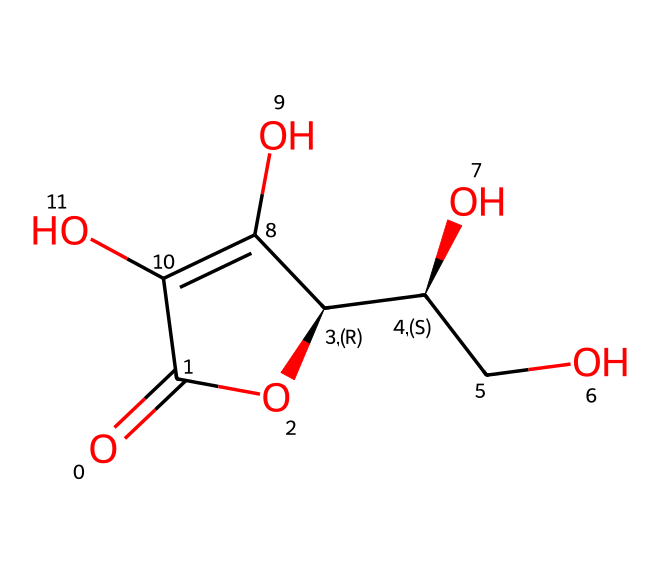How many carbon atoms are in ascorbic acid? To determine the number of carbon atoms, examine the structure and count each carbon atom present. The structure shows that there are 6 carbon atoms highlighted in the backbone of the molecule.
Answer: 6 What functional groups are present in ascorbic acid? By analyzing the structural representation, we can identify hydroxyl (-OH) groups and a carbonyl (C=O) group. These groups indicate that the chemical has alcohol and aldehyde functionalities.
Answer: hydroxyl and carbonyl Is ascorbic acid an organic acid or a mineral acid? Ascorbic acid is a compound primarily composed of carbon, hydrogen, and oxygen, fitting the definition of organic compounds. Thus, it is categorized as an organic acid.
Answer: organic acid What is the primary role of ascorbic acid in food preservation? Ascorbic acid primarily acts as an antioxidant in food preservation, helping to prevent oxidative damage in various food products, extending their shelf life.
Answer: antioxidant Which type of food additive is ascorbic acid classified as? Ascorbic acid is recognized as a preservative due to its ability to inhibit enzymatic browning and oxidation in foods, thus preventing spoilage.
Answer: preservative How many oxygen atoms are in ascorbic acid? By examining the chemical structure, we can count the number of oxygen atoms present. The molecule displays 6 oxygen atoms.
Answer: 6 What is the significance of the stereochemistry in ascorbic acid? The molecule contains specific stereocenters that influence its bioactivity and interaction with other molecules, affecting its function in food preservation and nutrition.
Answer: bioactivity 